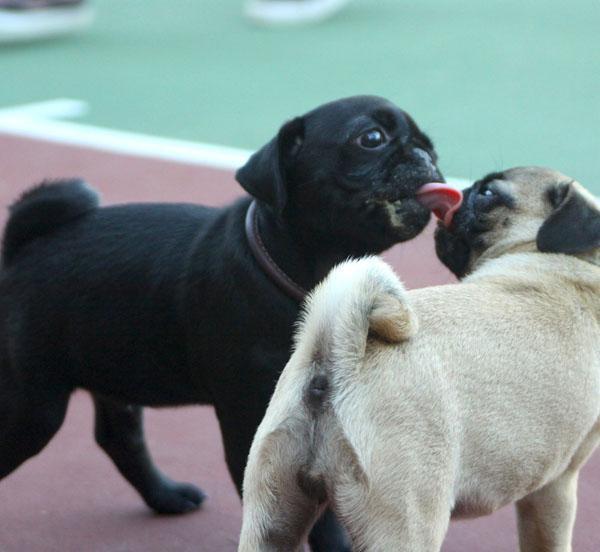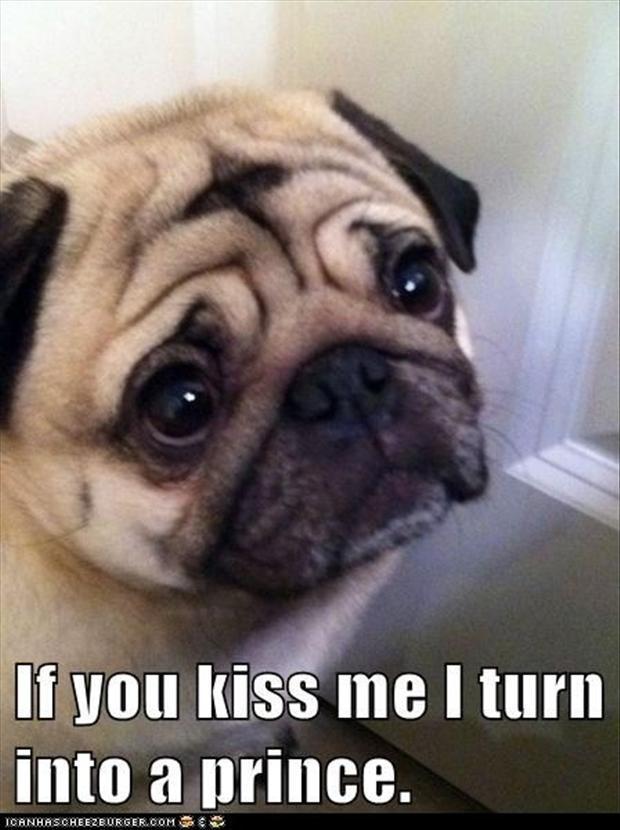The first image is the image on the left, the second image is the image on the right. Analyze the images presented: Is the assertion "The left and right image contains the same number of dogs." valid? Answer yes or no. No. 